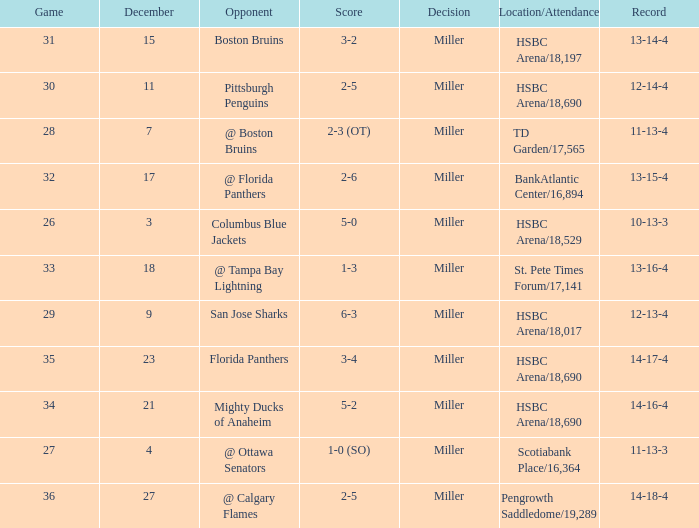Name the score for 29 game 6-3. 